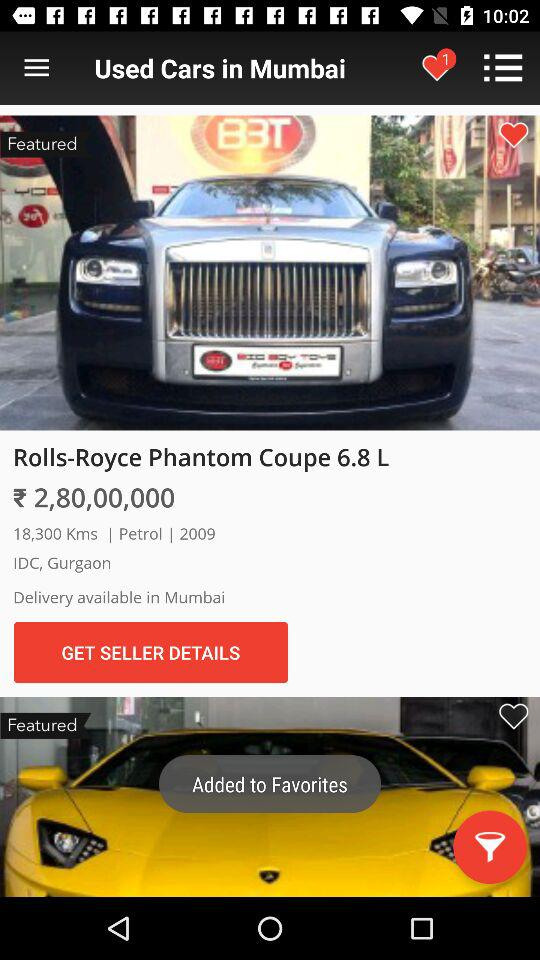What is the price of the Rolls-Royce Phantom Coupe? The price is ₹ 2,80,00,000. 